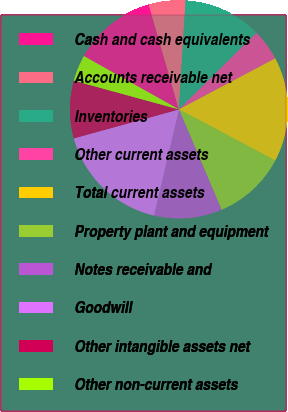Convert chart to OTSL. <chart><loc_0><loc_0><loc_500><loc_500><pie_chart><fcel>Cash and cash equivalents � �<fcel>Accounts receivable net� � � �<fcel>Inventories � � � � � � � � �<fcel>Other current assets � � � � �<fcel>Total current assets � � � � �<fcel>Property plant and equipment<fcel>Notes receivable and<fcel>Goodwill � � � � � � � � � � �<fcel>Other intangible assets net �<fcel>Other non-current assets � � �<nl><fcel>12.4%<fcel>5.43%<fcel>11.63%<fcel>4.65%<fcel>15.5%<fcel>10.85%<fcel>10.08%<fcel>17.05%<fcel>8.53%<fcel>3.88%<nl></chart> 